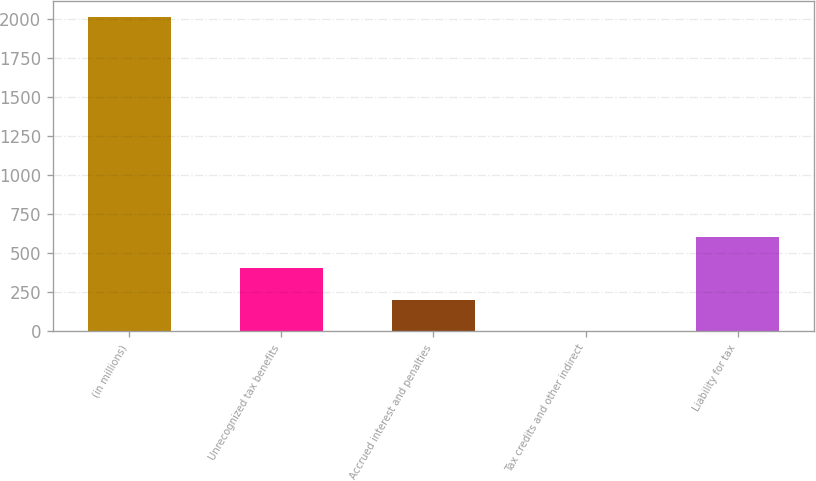Convert chart. <chart><loc_0><loc_0><loc_500><loc_500><bar_chart><fcel>(in millions)<fcel>Unrecognized tax benefits<fcel>Accrued interest and penalties<fcel>Tax credits and other indirect<fcel>Liability for tax<nl><fcel>2015<fcel>405.4<fcel>204.2<fcel>3<fcel>606.6<nl></chart> 